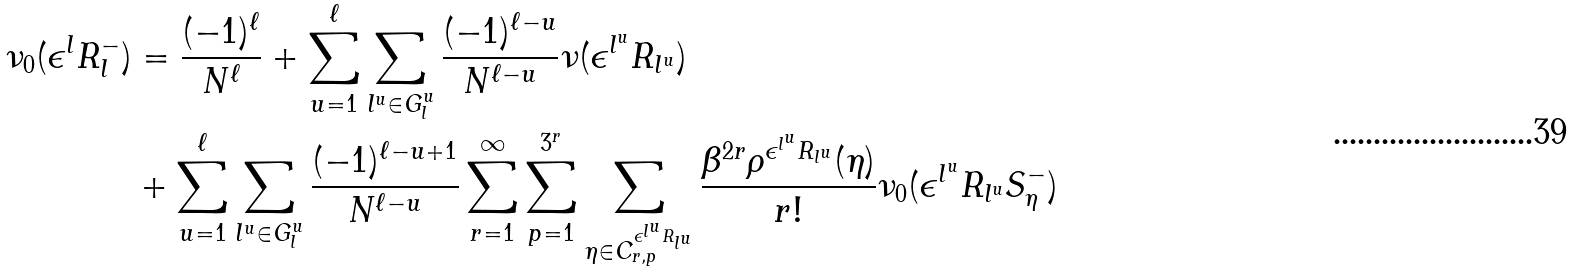<formula> <loc_0><loc_0><loc_500><loc_500>\nu _ { 0 } ( \epsilon ^ { l } R _ { l } ^ { - } ) & = \frac { ( - 1 ) ^ { \ell } } { N ^ { \ell } } + \sum _ { u = 1 } ^ { \ell } \sum _ { l ^ { u } \in G _ { l } ^ { u } } \frac { ( - 1 ) ^ { \ell - u } } { N ^ { \ell - u } } \nu ( \epsilon ^ { l ^ { u } } R _ { l ^ { u } } ) \\ & + \sum _ { u = 1 } ^ { \ell } \sum _ { l ^ { u } \in G _ { l } ^ { u } } \frac { ( - 1 ) ^ { \ell - u + 1 } } { N ^ { \ell - u } } \sum _ { r = 1 } ^ { \infty } \sum _ { p = 1 } ^ { 3 ^ { r } } \sum _ { \eta \in C ^ { \epsilon ^ { l ^ { u } } R _ { l ^ { u } } } _ { r , p } } \frac { \beta ^ { 2 r } \rho ^ { \epsilon ^ { l ^ { u } } R _ { l ^ { u } } } ( \eta ) } { r ! } \nu _ { 0 } ( \epsilon ^ { l ^ { u } } R _ { l ^ { u } } S _ { \eta } ^ { - } )</formula> 